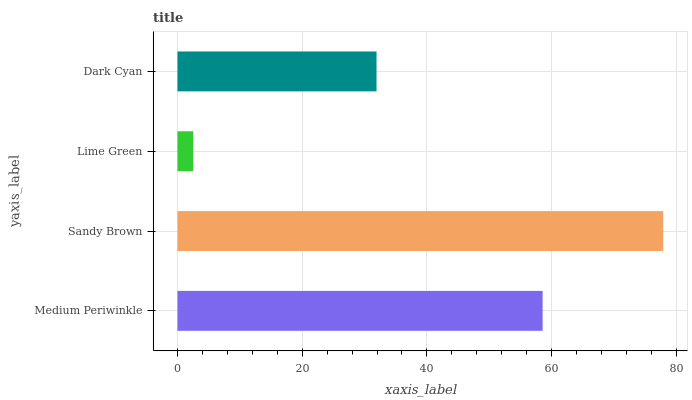Is Lime Green the minimum?
Answer yes or no. Yes. Is Sandy Brown the maximum?
Answer yes or no. Yes. Is Sandy Brown the minimum?
Answer yes or no. No. Is Lime Green the maximum?
Answer yes or no. No. Is Sandy Brown greater than Lime Green?
Answer yes or no. Yes. Is Lime Green less than Sandy Brown?
Answer yes or no. Yes. Is Lime Green greater than Sandy Brown?
Answer yes or no. No. Is Sandy Brown less than Lime Green?
Answer yes or no. No. Is Medium Periwinkle the high median?
Answer yes or no. Yes. Is Dark Cyan the low median?
Answer yes or no. Yes. Is Lime Green the high median?
Answer yes or no. No. Is Medium Periwinkle the low median?
Answer yes or no. No. 